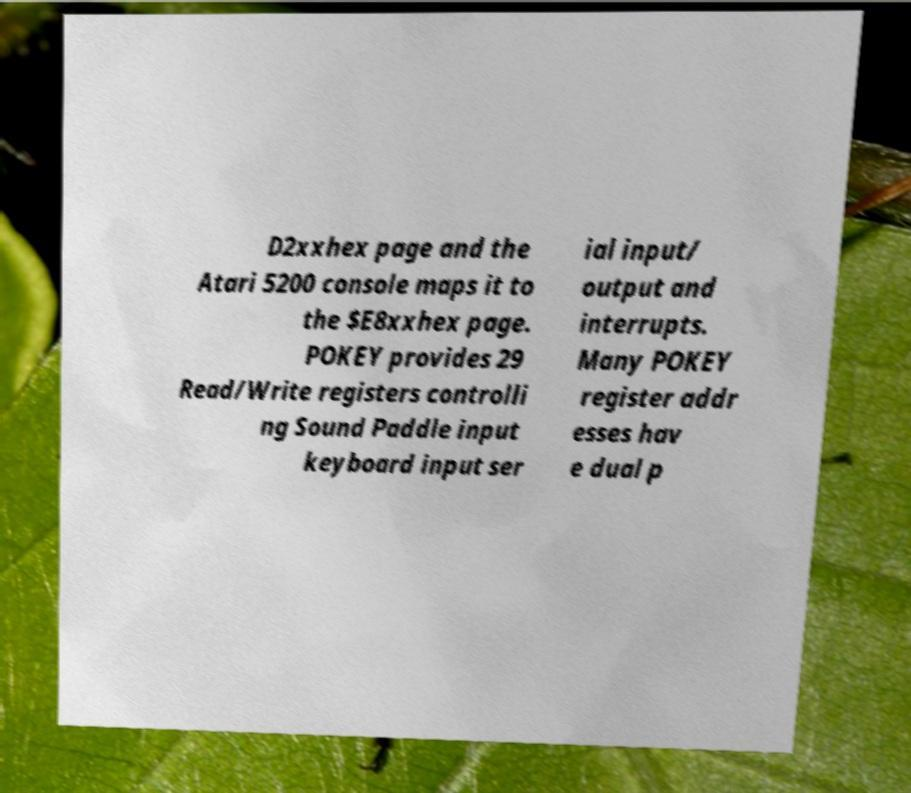For documentation purposes, I need the text within this image transcribed. Could you provide that? D2xxhex page and the Atari 5200 console maps it to the $E8xxhex page. POKEY provides 29 Read/Write registers controlli ng Sound Paddle input keyboard input ser ial input/ output and interrupts. Many POKEY register addr esses hav e dual p 